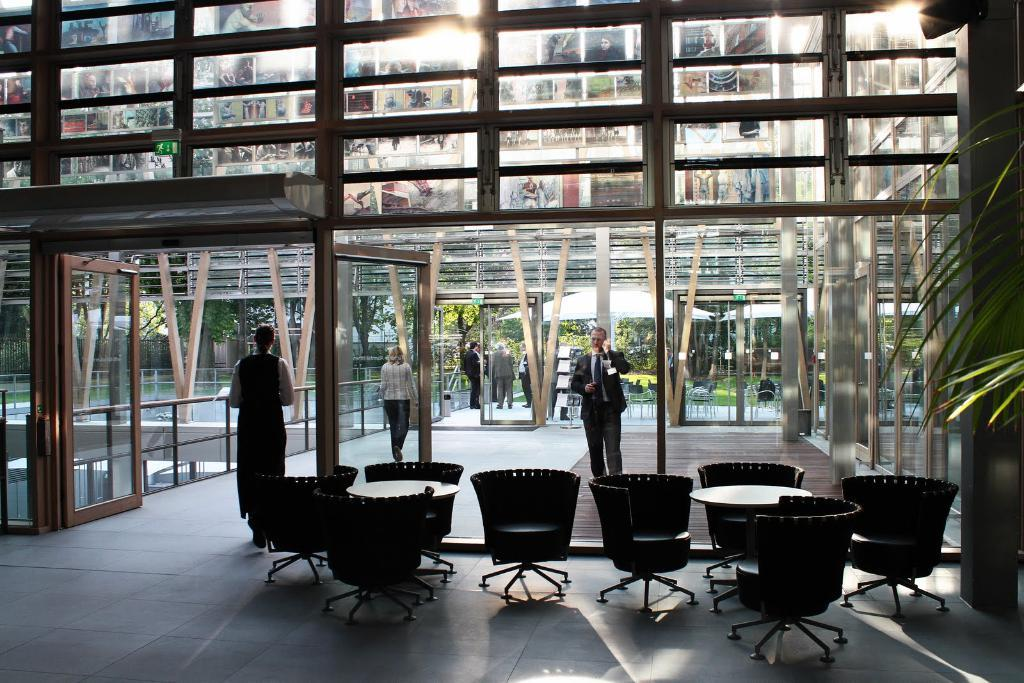What type of furniture is present in the image? There are black chairs and tables in the image. Where are the chairs and tables located? The chairs and tables are in front of a glass door. What can be seen outside the glass door? There are persons standing outside the glass door. How many sheep are visible through the glass door in the image? There are no sheep visible through the glass door in the image. What type of wound can be seen on the person standing outside the glass door? There is no wound visible on the person standing outside the glass door in the image. 